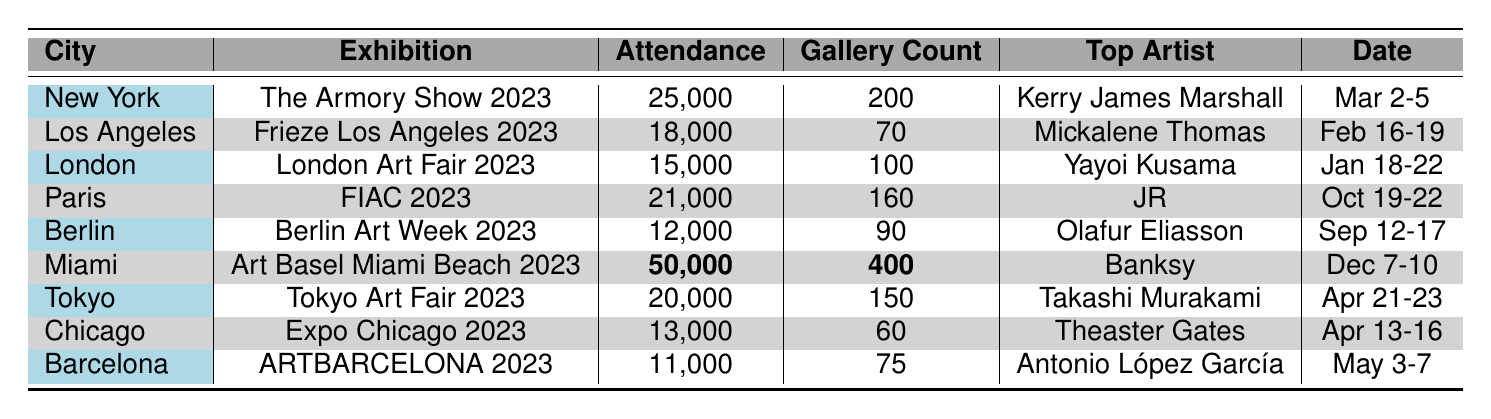What's the total attendance across all exhibitions? To find the total attendance, we add the attendance of each exhibition: 25000 + 18000 + 15000 + 21000 + 12000 + 50000 + 20000 + 13000 + 11000 = 172000
Answer: 172000 Which city had the highest gallery count? The highest gallery count in the table is 400, which is in Miami for Art Basel Miami Beach 2023
Answer: Miami Who was the top artist in Berlin? In Berlin, the top artist listed is Olafur Eliasson according to the table.
Answer: Olafur Eliasson How many cities had an attendance of over 15,000? The cities with attendance over 15,000 are New York, Paris, Miami, and Tokyo. That totals four cities.
Answer: 4 Is the attendance for the London Art Fair greater than that of the Expo Chicago? The attendance for the London Art Fair is 15,000 and for Expo Chicago, it is 13,000. Since 15,000 is greater than 13,000, the statement is true.
Answer: Yes What is the difference in attendance between the highest and lowest attended exhibitions? The highest attended exhibition is in Miami with 50,000 and the lowest is in Barcelona with 11,000. The difference is 50,000 - 11,000 = 39,000.
Answer: 39000 Which exhibition had the top artist with the highest name recognition? The artist Banksy, who is known internationally, has the highest recognition and is listed for the Miami exhibition, Art Basel Miami Beach 2023.
Answer: Art Basel Miami Beach 2023 What is the average attendance of the exhibitions held in February and March? The exhibitions in February and March are Frieze Los Angeles with 18,000 and The Armory Show with 25,000. The average is (18,000 + 25,000) / 2 = 21,500.
Answer: 21500 How many more galleries were present at Art Basel Miami than at Expo Chicago? Art Basel Miami Beach had 400 galleries while Expo Chicago had 60 galleries. The difference is 400 - 60 = 340 galleries.
Answer: 340 Which exhibition took place last in the year based on the dates? The exhibition that takes place last is Art Basel Miami Beach 2023, scheduled for December 7-10.
Answer: Art Basel Miami Beach 2023 